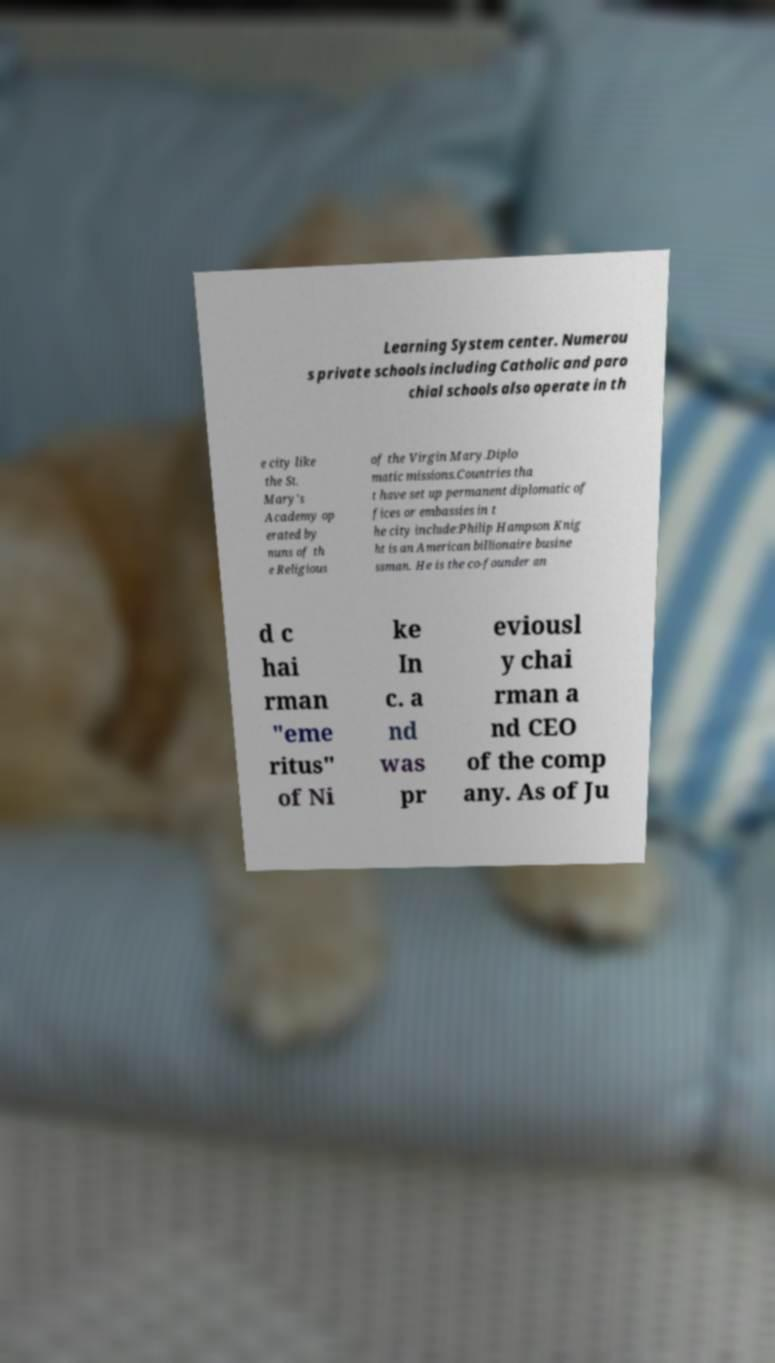Please identify and transcribe the text found in this image. Learning System center. Numerou s private schools including Catholic and paro chial schools also operate in th e city like the St. Mary's Academy op erated by nuns of th e Religious of the Virgin Mary.Diplo matic missions.Countries tha t have set up permanent diplomatic of fices or embassies in t he city include:Philip Hampson Knig ht is an American billionaire busine ssman. He is the co-founder an d c hai rman "eme ritus" of Ni ke In c. a nd was pr eviousl y chai rman a nd CEO of the comp any. As of Ju 